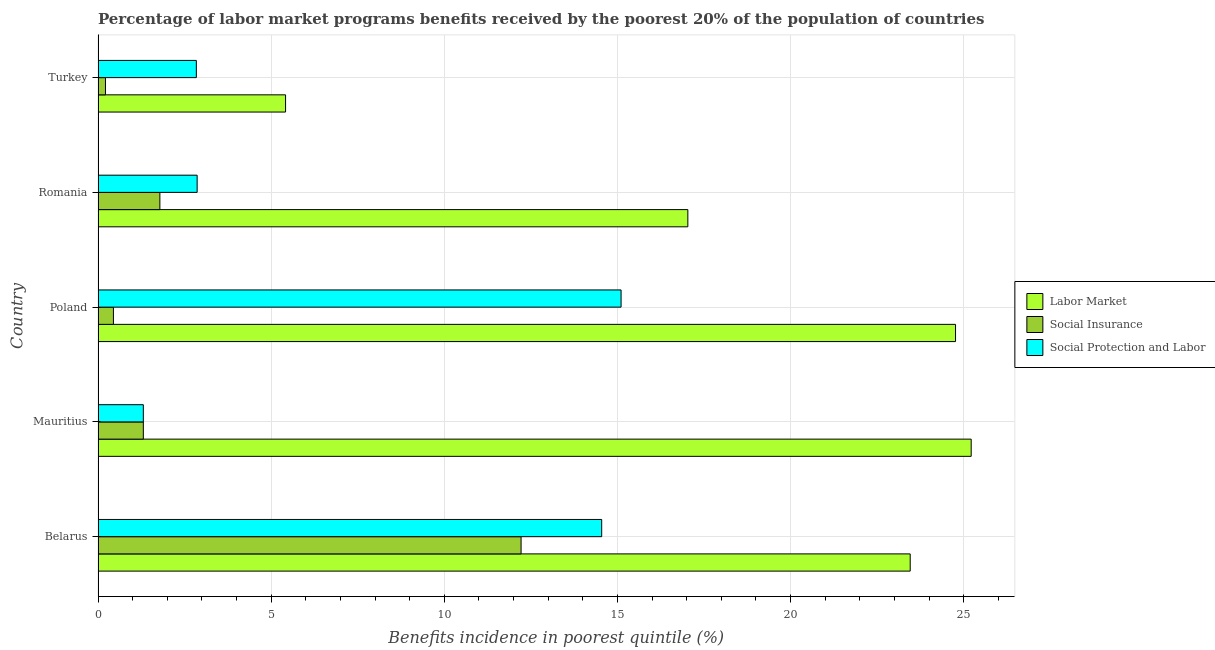How many different coloured bars are there?
Provide a short and direct response. 3. Are the number of bars on each tick of the Y-axis equal?
Ensure brevity in your answer.  Yes. How many bars are there on the 5th tick from the top?
Offer a very short reply. 3. What is the percentage of benefits received due to labor market programs in Poland?
Give a very brief answer. 24.76. Across all countries, what is the maximum percentage of benefits received due to social insurance programs?
Ensure brevity in your answer.  12.22. Across all countries, what is the minimum percentage of benefits received due to labor market programs?
Your response must be concise. 5.42. In which country was the percentage of benefits received due to labor market programs minimum?
Make the answer very short. Turkey. What is the total percentage of benefits received due to labor market programs in the graph?
Your response must be concise. 95.88. What is the difference between the percentage of benefits received due to social protection programs in Mauritius and that in Romania?
Provide a short and direct response. -1.55. What is the difference between the percentage of benefits received due to labor market programs in Romania and the percentage of benefits received due to social protection programs in Poland?
Your answer should be compact. 1.93. What is the average percentage of benefits received due to social protection programs per country?
Your response must be concise. 7.33. In how many countries, is the percentage of benefits received due to social insurance programs greater than 7 %?
Offer a very short reply. 1. What is the ratio of the percentage of benefits received due to social insurance programs in Mauritius to that in Turkey?
Your answer should be compact. 6.11. Is the difference between the percentage of benefits received due to social insurance programs in Mauritius and Poland greater than the difference between the percentage of benefits received due to social protection programs in Mauritius and Poland?
Keep it short and to the point. Yes. What is the difference between the highest and the second highest percentage of benefits received due to social insurance programs?
Provide a short and direct response. 10.43. Is the sum of the percentage of benefits received due to social protection programs in Mauritius and Poland greater than the maximum percentage of benefits received due to labor market programs across all countries?
Your answer should be compact. No. What does the 3rd bar from the top in Romania represents?
Provide a short and direct response. Labor Market. What does the 2nd bar from the bottom in Romania represents?
Your answer should be compact. Social Insurance. How many bars are there?
Offer a very short reply. 15. Are all the bars in the graph horizontal?
Provide a succinct answer. Yes. How many countries are there in the graph?
Provide a succinct answer. 5. How many legend labels are there?
Provide a short and direct response. 3. How are the legend labels stacked?
Keep it short and to the point. Vertical. What is the title of the graph?
Give a very brief answer. Percentage of labor market programs benefits received by the poorest 20% of the population of countries. What is the label or title of the X-axis?
Keep it short and to the point. Benefits incidence in poorest quintile (%). What is the Benefits incidence in poorest quintile (%) of Labor Market in Belarus?
Offer a very short reply. 23.45. What is the Benefits incidence in poorest quintile (%) in Social Insurance in Belarus?
Offer a terse response. 12.22. What is the Benefits incidence in poorest quintile (%) in Social Protection and Labor in Belarus?
Provide a short and direct response. 14.54. What is the Benefits incidence in poorest quintile (%) of Labor Market in Mauritius?
Ensure brevity in your answer.  25.22. What is the Benefits incidence in poorest quintile (%) of Social Insurance in Mauritius?
Provide a succinct answer. 1.31. What is the Benefits incidence in poorest quintile (%) of Social Protection and Labor in Mauritius?
Your answer should be very brief. 1.31. What is the Benefits incidence in poorest quintile (%) of Labor Market in Poland?
Make the answer very short. 24.76. What is the Benefits incidence in poorest quintile (%) of Social Insurance in Poland?
Offer a terse response. 0.44. What is the Benefits incidence in poorest quintile (%) of Social Protection and Labor in Poland?
Offer a very short reply. 15.1. What is the Benefits incidence in poorest quintile (%) in Labor Market in Romania?
Offer a terse response. 17.03. What is the Benefits incidence in poorest quintile (%) in Social Insurance in Romania?
Provide a succinct answer. 1.79. What is the Benefits incidence in poorest quintile (%) of Social Protection and Labor in Romania?
Make the answer very short. 2.86. What is the Benefits incidence in poorest quintile (%) in Labor Market in Turkey?
Give a very brief answer. 5.42. What is the Benefits incidence in poorest quintile (%) in Social Insurance in Turkey?
Your response must be concise. 0.21. What is the Benefits incidence in poorest quintile (%) of Social Protection and Labor in Turkey?
Provide a short and direct response. 2.84. Across all countries, what is the maximum Benefits incidence in poorest quintile (%) in Labor Market?
Offer a terse response. 25.22. Across all countries, what is the maximum Benefits incidence in poorest quintile (%) of Social Insurance?
Provide a short and direct response. 12.22. Across all countries, what is the maximum Benefits incidence in poorest quintile (%) of Social Protection and Labor?
Your answer should be very brief. 15.1. Across all countries, what is the minimum Benefits incidence in poorest quintile (%) in Labor Market?
Make the answer very short. 5.42. Across all countries, what is the minimum Benefits incidence in poorest quintile (%) of Social Insurance?
Ensure brevity in your answer.  0.21. Across all countries, what is the minimum Benefits incidence in poorest quintile (%) of Social Protection and Labor?
Your answer should be compact. 1.31. What is the total Benefits incidence in poorest quintile (%) of Labor Market in the graph?
Make the answer very short. 95.88. What is the total Benefits incidence in poorest quintile (%) of Social Insurance in the graph?
Provide a succinct answer. 15.97. What is the total Benefits incidence in poorest quintile (%) in Social Protection and Labor in the graph?
Keep it short and to the point. 36.66. What is the difference between the Benefits incidence in poorest quintile (%) of Labor Market in Belarus and that in Mauritius?
Give a very brief answer. -1.76. What is the difference between the Benefits incidence in poorest quintile (%) in Social Insurance in Belarus and that in Mauritius?
Provide a succinct answer. 10.91. What is the difference between the Benefits incidence in poorest quintile (%) in Social Protection and Labor in Belarus and that in Mauritius?
Provide a short and direct response. 13.24. What is the difference between the Benefits incidence in poorest quintile (%) in Labor Market in Belarus and that in Poland?
Ensure brevity in your answer.  -1.31. What is the difference between the Benefits incidence in poorest quintile (%) in Social Insurance in Belarus and that in Poland?
Make the answer very short. 11.77. What is the difference between the Benefits incidence in poorest quintile (%) in Social Protection and Labor in Belarus and that in Poland?
Your answer should be very brief. -0.56. What is the difference between the Benefits incidence in poorest quintile (%) of Labor Market in Belarus and that in Romania?
Provide a succinct answer. 6.42. What is the difference between the Benefits incidence in poorest quintile (%) in Social Insurance in Belarus and that in Romania?
Offer a very short reply. 10.43. What is the difference between the Benefits incidence in poorest quintile (%) of Social Protection and Labor in Belarus and that in Romania?
Keep it short and to the point. 11.68. What is the difference between the Benefits incidence in poorest quintile (%) of Labor Market in Belarus and that in Turkey?
Offer a terse response. 18.04. What is the difference between the Benefits incidence in poorest quintile (%) of Social Insurance in Belarus and that in Turkey?
Offer a terse response. 12. What is the difference between the Benefits incidence in poorest quintile (%) in Social Protection and Labor in Belarus and that in Turkey?
Give a very brief answer. 11.71. What is the difference between the Benefits incidence in poorest quintile (%) in Labor Market in Mauritius and that in Poland?
Ensure brevity in your answer.  0.45. What is the difference between the Benefits incidence in poorest quintile (%) in Social Insurance in Mauritius and that in Poland?
Your answer should be compact. 0.86. What is the difference between the Benefits incidence in poorest quintile (%) of Social Protection and Labor in Mauritius and that in Poland?
Give a very brief answer. -13.8. What is the difference between the Benefits incidence in poorest quintile (%) in Labor Market in Mauritius and that in Romania?
Provide a short and direct response. 8.18. What is the difference between the Benefits incidence in poorest quintile (%) of Social Insurance in Mauritius and that in Romania?
Your answer should be very brief. -0.48. What is the difference between the Benefits incidence in poorest quintile (%) of Social Protection and Labor in Mauritius and that in Romania?
Ensure brevity in your answer.  -1.55. What is the difference between the Benefits incidence in poorest quintile (%) in Labor Market in Mauritius and that in Turkey?
Ensure brevity in your answer.  19.8. What is the difference between the Benefits incidence in poorest quintile (%) of Social Insurance in Mauritius and that in Turkey?
Offer a very short reply. 1.09. What is the difference between the Benefits incidence in poorest quintile (%) in Social Protection and Labor in Mauritius and that in Turkey?
Your answer should be very brief. -1.53. What is the difference between the Benefits incidence in poorest quintile (%) in Labor Market in Poland and that in Romania?
Keep it short and to the point. 7.73. What is the difference between the Benefits incidence in poorest quintile (%) in Social Insurance in Poland and that in Romania?
Your response must be concise. -1.34. What is the difference between the Benefits incidence in poorest quintile (%) in Social Protection and Labor in Poland and that in Romania?
Your answer should be very brief. 12.24. What is the difference between the Benefits incidence in poorest quintile (%) in Labor Market in Poland and that in Turkey?
Make the answer very short. 19.35. What is the difference between the Benefits incidence in poorest quintile (%) of Social Insurance in Poland and that in Turkey?
Keep it short and to the point. 0.23. What is the difference between the Benefits incidence in poorest quintile (%) of Social Protection and Labor in Poland and that in Turkey?
Give a very brief answer. 12.27. What is the difference between the Benefits incidence in poorest quintile (%) of Labor Market in Romania and that in Turkey?
Give a very brief answer. 11.62. What is the difference between the Benefits incidence in poorest quintile (%) of Social Insurance in Romania and that in Turkey?
Your answer should be very brief. 1.57. What is the difference between the Benefits incidence in poorest quintile (%) in Social Protection and Labor in Romania and that in Turkey?
Give a very brief answer. 0.02. What is the difference between the Benefits incidence in poorest quintile (%) in Labor Market in Belarus and the Benefits incidence in poorest quintile (%) in Social Insurance in Mauritius?
Offer a terse response. 22.15. What is the difference between the Benefits incidence in poorest quintile (%) in Labor Market in Belarus and the Benefits incidence in poorest quintile (%) in Social Protection and Labor in Mauritius?
Offer a very short reply. 22.15. What is the difference between the Benefits incidence in poorest quintile (%) in Social Insurance in Belarus and the Benefits incidence in poorest quintile (%) in Social Protection and Labor in Mauritius?
Provide a succinct answer. 10.91. What is the difference between the Benefits incidence in poorest quintile (%) in Labor Market in Belarus and the Benefits incidence in poorest quintile (%) in Social Insurance in Poland?
Offer a very short reply. 23.01. What is the difference between the Benefits incidence in poorest quintile (%) in Labor Market in Belarus and the Benefits incidence in poorest quintile (%) in Social Protection and Labor in Poland?
Offer a terse response. 8.35. What is the difference between the Benefits incidence in poorest quintile (%) of Social Insurance in Belarus and the Benefits incidence in poorest quintile (%) of Social Protection and Labor in Poland?
Offer a very short reply. -2.89. What is the difference between the Benefits incidence in poorest quintile (%) in Labor Market in Belarus and the Benefits incidence in poorest quintile (%) in Social Insurance in Romania?
Ensure brevity in your answer.  21.67. What is the difference between the Benefits incidence in poorest quintile (%) of Labor Market in Belarus and the Benefits incidence in poorest quintile (%) of Social Protection and Labor in Romania?
Your response must be concise. 20.59. What is the difference between the Benefits incidence in poorest quintile (%) of Social Insurance in Belarus and the Benefits incidence in poorest quintile (%) of Social Protection and Labor in Romania?
Make the answer very short. 9.36. What is the difference between the Benefits incidence in poorest quintile (%) in Labor Market in Belarus and the Benefits incidence in poorest quintile (%) in Social Insurance in Turkey?
Ensure brevity in your answer.  23.24. What is the difference between the Benefits incidence in poorest quintile (%) in Labor Market in Belarus and the Benefits incidence in poorest quintile (%) in Social Protection and Labor in Turkey?
Ensure brevity in your answer.  20.62. What is the difference between the Benefits incidence in poorest quintile (%) in Social Insurance in Belarus and the Benefits incidence in poorest quintile (%) in Social Protection and Labor in Turkey?
Keep it short and to the point. 9.38. What is the difference between the Benefits incidence in poorest quintile (%) in Labor Market in Mauritius and the Benefits incidence in poorest quintile (%) in Social Insurance in Poland?
Offer a very short reply. 24.77. What is the difference between the Benefits incidence in poorest quintile (%) of Labor Market in Mauritius and the Benefits incidence in poorest quintile (%) of Social Protection and Labor in Poland?
Give a very brief answer. 10.11. What is the difference between the Benefits incidence in poorest quintile (%) of Social Insurance in Mauritius and the Benefits incidence in poorest quintile (%) of Social Protection and Labor in Poland?
Provide a short and direct response. -13.8. What is the difference between the Benefits incidence in poorest quintile (%) in Labor Market in Mauritius and the Benefits incidence in poorest quintile (%) in Social Insurance in Romania?
Your answer should be compact. 23.43. What is the difference between the Benefits incidence in poorest quintile (%) in Labor Market in Mauritius and the Benefits incidence in poorest quintile (%) in Social Protection and Labor in Romania?
Your answer should be compact. 22.35. What is the difference between the Benefits incidence in poorest quintile (%) of Social Insurance in Mauritius and the Benefits incidence in poorest quintile (%) of Social Protection and Labor in Romania?
Your answer should be compact. -1.55. What is the difference between the Benefits incidence in poorest quintile (%) of Labor Market in Mauritius and the Benefits incidence in poorest quintile (%) of Social Insurance in Turkey?
Give a very brief answer. 25. What is the difference between the Benefits incidence in poorest quintile (%) in Labor Market in Mauritius and the Benefits incidence in poorest quintile (%) in Social Protection and Labor in Turkey?
Provide a short and direct response. 22.38. What is the difference between the Benefits incidence in poorest quintile (%) in Social Insurance in Mauritius and the Benefits incidence in poorest quintile (%) in Social Protection and Labor in Turkey?
Keep it short and to the point. -1.53. What is the difference between the Benefits incidence in poorest quintile (%) in Labor Market in Poland and the Benefits incidence in poorest quintile (%) in Social Insurance in Romania?
Ensure brevity in your answer.  22.98. What is the difference between the Benefits incidence in poorest quintile (%) in Labor Market in Poland and the Benefits incidence in poorest quintile (%) in Social Protection and Labor in Romania?
Offer a terse response. 21.9. What is the difference between the Benefits incidence in poorest quintile (%) in Social Insurance in Poland and the Benefits incidence in poorest quintile (%) in Social Protection and Labor in Romania?
Provide a succinct answer. -2.42. What is the difference between the Benefits incidence in poorest quintile (%) of Labor Market in Poland and the Benefits incidence in poorest quintile (%) of Social Insurance in Turkey?
Give a very brief answer. 24.55. What is the difference between the Benefits incidence in poorest quintile (%) of Labor Market in Poland and the Benefits incidence in poorest quintile (%) of Social Protection and Labor in Turkey?
Give a very brief answer. 21.92. What is the difference between the Benefits incidence in poorest quintile (%) of Social Insurance in Poland and the Benefits incidence in poorest quintile (%) of Social Protection and Labor in Turkey?
Ensure brevity in your answer.  -2.39. What is the difference between the Benefits incidence in poorest quintile (%) of Labor Market in Romania and the Benefits incidence in poorest quintile (%) of Social Insurance in Turkey?
Offer a terse response. 16.82. What is the difference between the Benefits incidence in poorest quintile (%) of Labor Market in Romania and the Benefits incidence in poorest quintile (%) of Social Protection and Labor in Turkey?
Keep it short and to the point. 14.19. What is the difference between the Benefits incidence in poorest quintile (%) in Social Insurance in Romania and the Benefits incidence in poorest quintile (%) in Social Protection and Labor in Turkey?
Offer a very short reply. -1.05. What is the average Benefits incidence in poorest quintile (%) of Labor Market per country?
Your response must be concise. 19.18. What is the average Benefits incidence in poorest quintile (%) of Social Insurance per country?
Offer a very short reply. 3.19. What is the average Benefits incidence in poorest quintile (%) in Social Protection and Labor per country?
Keep it short and to the point. 7.33. What is the difference between the Benefits incidence in poorest quintile (%) in Labor Market and Benefits incidence in poorest quintile (%) in Social Insurance in Belarus?
Give a very brief answer. 11.24. What is the difference between the Benefits incidence in poorest quintile (%) in Labor Market and Benefits incidence in poorest quintile (%) in Social Protection and Labor in Belarus?
Your response must be concise. 8.91. What is the difference between the Benefits incidence in poorest quintile (%) of Social Insurance and Benefits incidence in poorest quintile (%) of Social Protection and Labor in Belarus?
Give a very brief answer. -2.33. What is the difference between the Benefits incidence in poorest quintile (%) in Labor Market and Benefits incidence in poorest quintile (%) in Social Insurance in Mauritius?
Offer a very short reply. 23.91. What is the difference between the Benefits incidence in poorest quintile (%) in Labor Market and Benefits incidence in poorest quintile (%) in Social Protection and Labor in Mauritius?
Your answer should be very brief. 23.91. What is the difference between the Benefits incidence in poorest quintile (%) in Labor Market and Benefits incidence in poorest quintile (%) in Social Insurance in Poland?
Keep it short and to the point. 24.32. What is the difference between the Benefits incidence in poorest quintile (%) of Labor Market and Benefits incidence in poorest quintile (%) of Social Protection and Labor in Poland?
Ensure brevity in your answer.  9.66. What is the difference between the Benefits incidence in poorest quintile (%) of Social Insurance and Benefits incidence in poorest quintile (%) of Social Protection and Labor in Poland?
Ensure brevity in your answer.  -14.66. What is the difference between the Benefits incidence in poorest quintile (%) in Labor Market and Benefits incidence in poorest quintile (%) in Social Insurance in Romania?
Offer a terse response. 15.25. What is the difference between the Benefits incidence in poorest quintile (%) in Labor Market and Benefits incidence in poorest quintile (%) in Social Protection and Labor in Romania?
Provide a succinct answer. 14.17. What is the difference between the Benefits incidence in poorest quintile (%) in Social Insurance and Benefits incidence in poorest quintile (%) in Social Protection and Labor in Romania?
Ensure brevity in your answer.  -1.08. What is the difference between the Benefits incidence in poorest quintile (%) of Labor Market and Benefits incidence in poorest quintile (%) of Social Insurance in Turkey?
Your answer should be very brief. 5.2. What is the difference between the Benefits incidence in poorest quintile (%) of Labor Market and Benefits incidence in poorest quintile (%) of Social Protection and Labor in Turkey?
Make the answer very short. 2.58. What is the difference between the Benefits incidence in poorest quintile (%) in Social Insurance and Benefits incidence in poorest quintile (%) in Social Protection and Labor in Turkey?
Ensure brevity in your answer.  -2.62. What is the ratio of the Benefits incidence in poorest quintile (%) of Labor Market in Belarus to that in Mauritius?
Your response must be concise. 0.93. What is the ratio of the Benefits incidence in poorest quintile (%) in Social Insurance in Belarus to that in Mauritius?
Make the answer very short. 9.34. What is the ratio of the Benefits incidence in poorest quintile (%) of Social Protection and Labor in Belarus to that in Mauritius?
Your response must be concise. 11.12. What is the ratio of the Benefits incidence in poorest quintile (%) of Labor Market in Belarus to that in Poland?
Your answer should be compact. 0.95. What is the ratio of the Benefits incidence in poorest quintile (%) of Social Insurance in Belarus to that in Poland?
Your response must be concise. 27.51. What is the ratio of the Benefits incidence in poorest quintile (%) of Social Protection and Labor in Belarus to that in Poland?
Keep it short and to the point. 0.96. What is the ratio of the Benefits incidence in poorest quintile (%) of Labor Market in Belarus to that in Romania?
Give a very brief answer. 1.38. What is the ratio of the Benefits incidence in poorest quintile (%) of Social Insurance in Belarus to that in Romania?
Keep it short and to the point. 6.84. What is the ratio of the Benefits incidence in poorest quintile (%) of Social Protection and Labor in Belarus to that in Romania?
Give a very brief answer. 5.08. What is the ratio of the Benefits incidence in poorest quintile (%) of Labor Market in Belarus to that in Turkey?
Ensure brevity in your answer.  4.33. What is the ratio of the Benefits incidence in poorest quintile (%) in Social Insurance in Belarus to that in Turkey?
Your answer should be compact. 57.07. What is the ratio of the Benefits incidence in poorest quintile (%) of Social Protection and Labor in Belarus to that in Turkey?
Keep it short and to the point. 5.12. What is the ratio of the Benefits incidence in poorest quintile (%) of Labor Market in Mauritius to that in Poland?
Make the answer very short. 1.02. What is the ratio of the Benefits incidence in poorest quintile (%) in Social Insurance in Mauritius to that in Poland?
Ensure brevity in your answer.  2.95. What is the ratio of the Benefits incidence in poorest quintile (%) in Social Protection and Labor in Mauritius to that in Poland?
Offer a very short reply. 0.09. What is the ratio of the Benefits incidence in poorest quintile (%) in Labor Market in Mauritius to that in Romania?
Offer a very short reply. 1.48. What is the ratio of the Benefits incidence in poorest quintile (%) in Social Insurance in Mauritius to that in Romania?
Your response must be concise. 0.73. What is the ratio of the Benefits incidence in poorest quintile (%) of Social Protection and Labor in Mauritius to that in Romania?
Provide a succinct answer. 0.46. What is the ratio of the Benefits incidence in poorest quintile (%) in Labor Market in Mauritius to that in Turkey?
Provide a short and direct response. 4.66. What is the ratio of the Benefits incidence in poorest quintile (%) of Social Insurance in Mauritius to that in Turkey?
Offer a very short reply. 6.11. What is the ratio of the Benefits incidence in poorest quintile (%) of Social Protection and Labor in Mauritius to that in Turkey?
Your answer should be very brief. 0.46. What is the ratio of the Benefits incidence in poorest quintile (%) of Labor Market in Poland to that in Romania?
Offer a terse response. 1.45. What is the ratio of the Benefits incidence in poorest quintile (%) of Social Insurance in Poland to that in Romania?
Ensure brevity in your answer.  0.25. What is the ratio of the Benefits incidence in poorest quintile (%) of Social Protection and Labor in Poland to that in Romania?
Your answer should be compact. 5.28. What is the ratio of the Benefits incidence in poorest quintile (%) of Labor Market in Poland to that in Turkey?
Keep it short and to the point. 4.57. What is the ratio of the Benefits incidence in poorest quintile (%) in Social Insurance in Poland to that in Turkey?
Offer a very short reply. 2.07. What is the ratio of the Benefits incidence in poorest quintile (%) of Social Protection and Labor in Poland to that in Turkey?
Give a very brief answer. 5.32. What is the ratio of the Benefits incidence in poorest quintile (%) of Labor Market in Romania to that in Turkey?
Provide a succinct answer. 3.15. What is the ratio of the Benefits incidence in poorest quintile (%) of Social Insurance in Romania to that in Turkey?
Offer a very short reply. 8.34. What is the difference between the highest and the second highest Benefits incidence in poorest quintile (%) in Labor Market?
Provide a short and direct response. 0.45. What is the difference between the highest and the second highest Benefits incidence in poorest quintile (%) in Social Insurance?
Ensure brevity in your answer.  10.43. What is the difference between the highest and the second highest Benefits incidence in poorest quintile (%) of Social Protection and Labor?
Keep it short and to the point. 0.56. What is the difference between the highest and the lowest Benefits incidence in poorest quintile (%) of Labor Market?
Make the answer very short. 19.8. What is the difference between the highest and the lowest Benefits incidence in poorest quintile (%) in Social Insurance?
Your answer should be very brief. 12. What is the difference between the highest and the lowest Benefits incidence in poorest quintile (%) in Social Protection and Labor?
Ensure brevity in your answer.  13.8. 